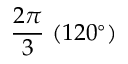Convert formula to latex. <formula><loc_0><loc_0><loc_500><loc_500>{ \frac { 2 \pi } { 3 } } \ ( 1 2 0 ^ { \circ } )</formula> 